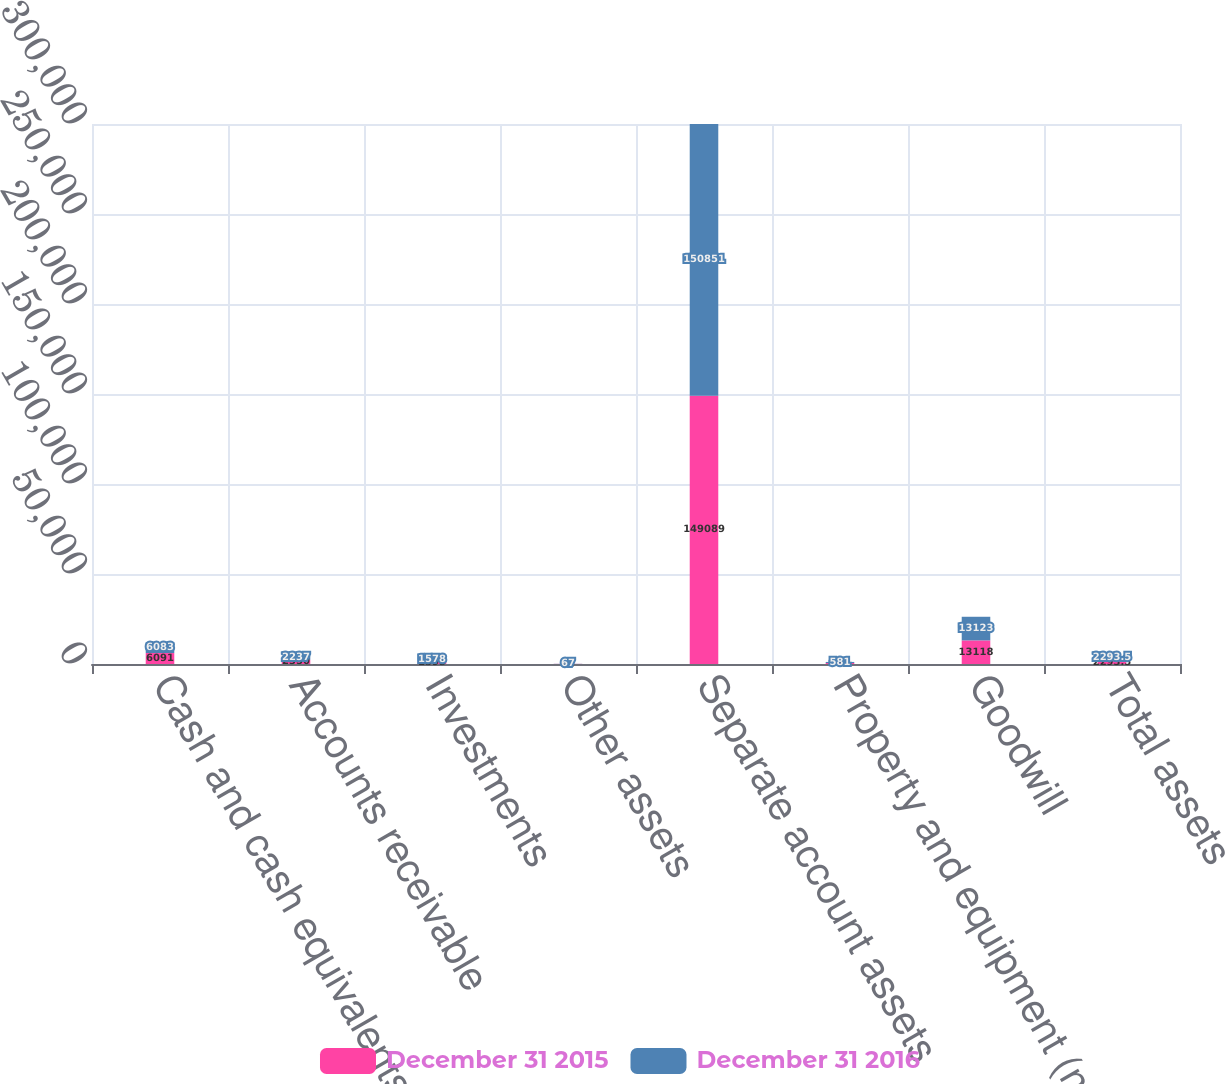Convert chart. <chart><loc_0><loc_0><loc_500><loc_500><stacked_bar_chart><ecel><fcel>Cash and cash equivalents<fcel>Accounts receivable<fcel>Investments<fcel>Other assets<fcel>Separate account assets<fcel>Property and equipment (net of<fcel>Goodwill<fcel>Total assets<nl><fcel>December 31 2015<fcel>6091<fcel>2350<fcel>1595<fcel>63<fcel>149089<fcel>559<fcel>13118<fcel>2293.5<nl><fcel>December 31 2016<fcel>6083<fcel>2237<fcel>1578<fcel>67<fcel>150851<fcel>581<fcel>13123<fcel>2293.5<nl></chart> 